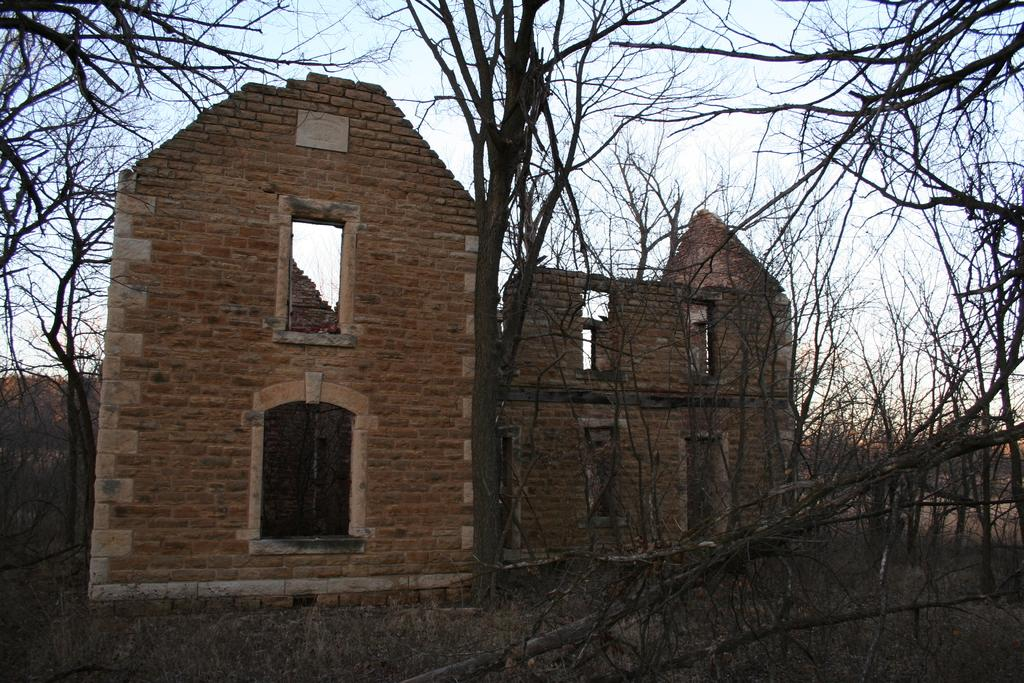What type of vegetation is present in the image? There are many trees in the image. What covers the ground in the image? There is grass on the ground. What type of building can be seen in the image? There is a building with a brick wall in the image. What can be seen in the background of the image? The sky is visible in the background of the image. What type of machine can be seen producing thunder in the image? There is no machine or thunder present in the image. Is there any ice visible in the image? There is no ice present in the image. 